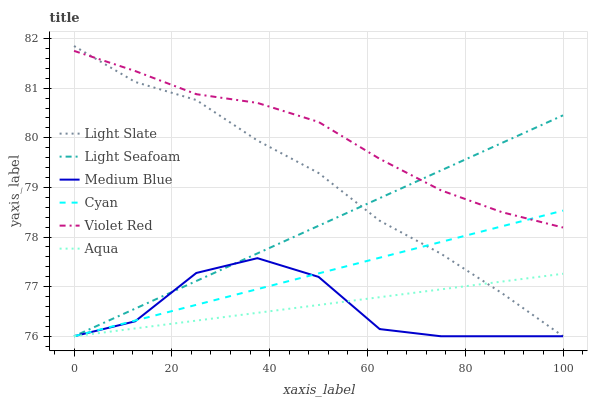Does Medium Blue have the minimum area under the curve?
Answer yes or no. Yes. Does Violet Red have the maximum area under the curve?
Answer yes or no. Yes. Does Light Slate have the minimum area under the curve?
Answer yes or no. No. Does Light Slate have the maximum area under the curve?
Answer yes or no. No. Is Light Seafoam the smoothest?
Answer yes or no. Yes. Is Medium Blue the roughest?
Answer yes or no. Yes. Is Light Slate the smoothest?
Answer yes or no. No. Is Light Slate the roughest?
Answer yes or no. No. Does Aqua have the highest value?
Answer yes or no. No. Is Aqua less than Violet Red?
Answer yes or no. Yes. Is Violet Red greater than Medium Blue?
Answer yes or no. Yes. Does Aqua intersect Violet Red?
Answer yes or no. No. 